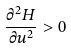<formula> <loc_0><loc_0><loc_500><loc_500>\frac { \partial ^ { 2 } H } { \partial u ^ { 2 } } > 0</formula> 